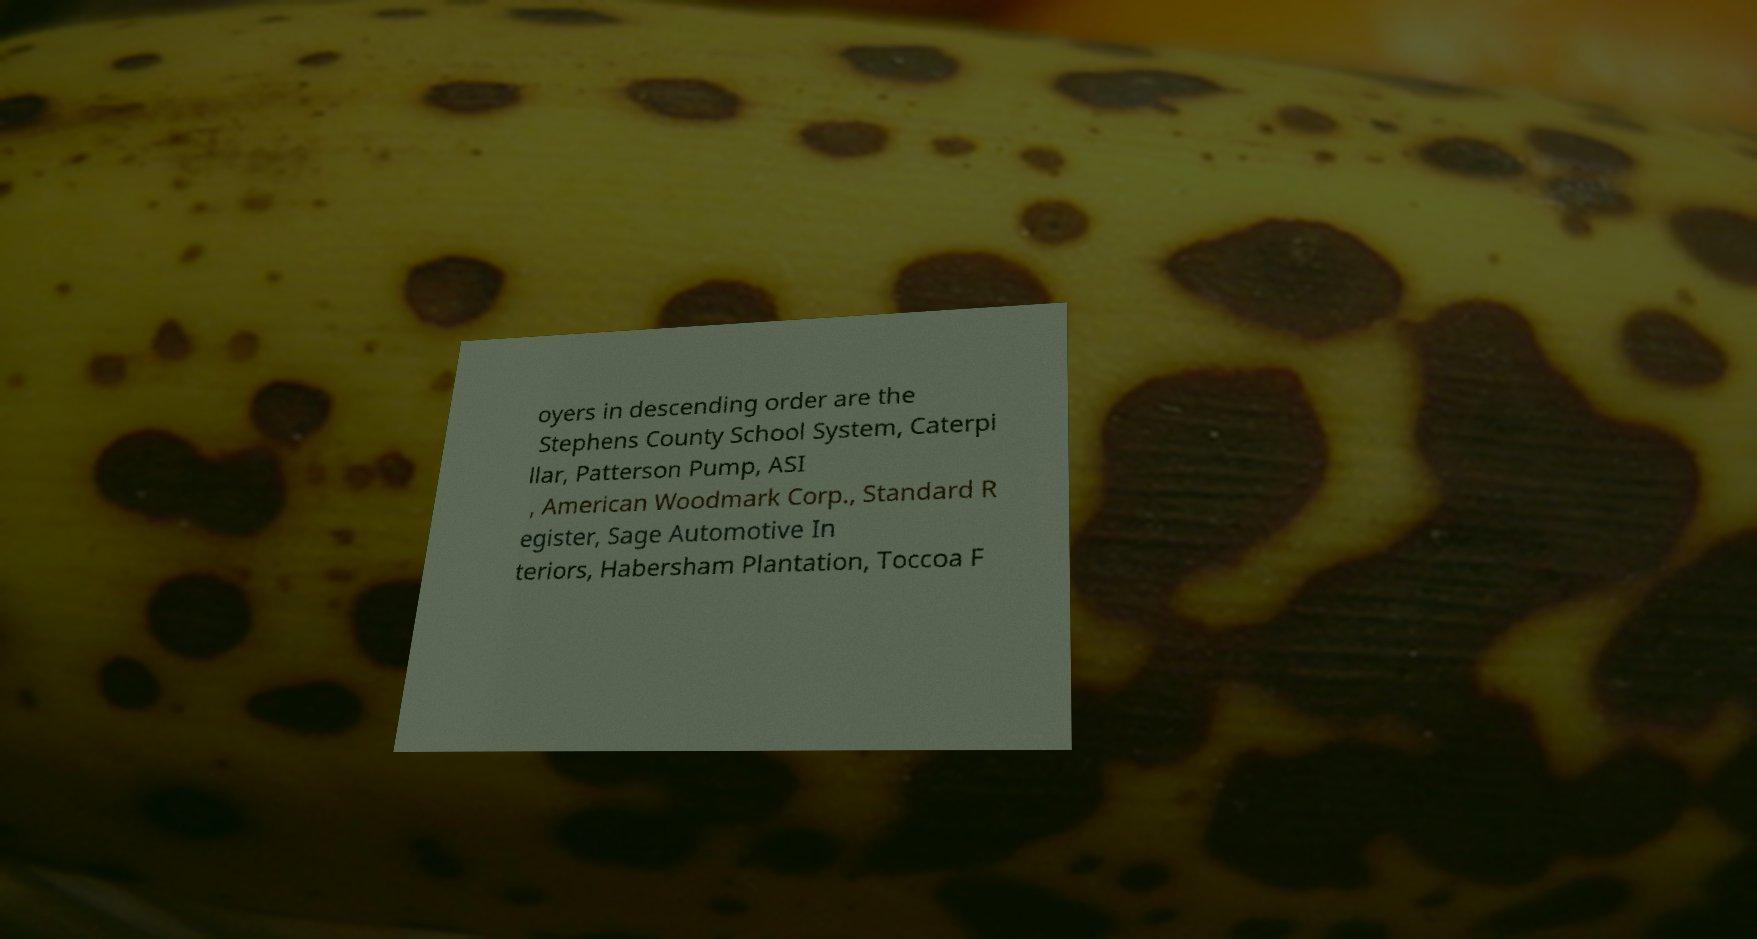For documentation purposes, I need the text within this image transcribed. Could you provide that? oyers in descending order are the Stephens County School System, Caterpi llar, Patterson Pump, ASI , American Woodmark Corp., Standard R egister, Sage Automotive In teriors, Habersham Plantation, Toccoa F 